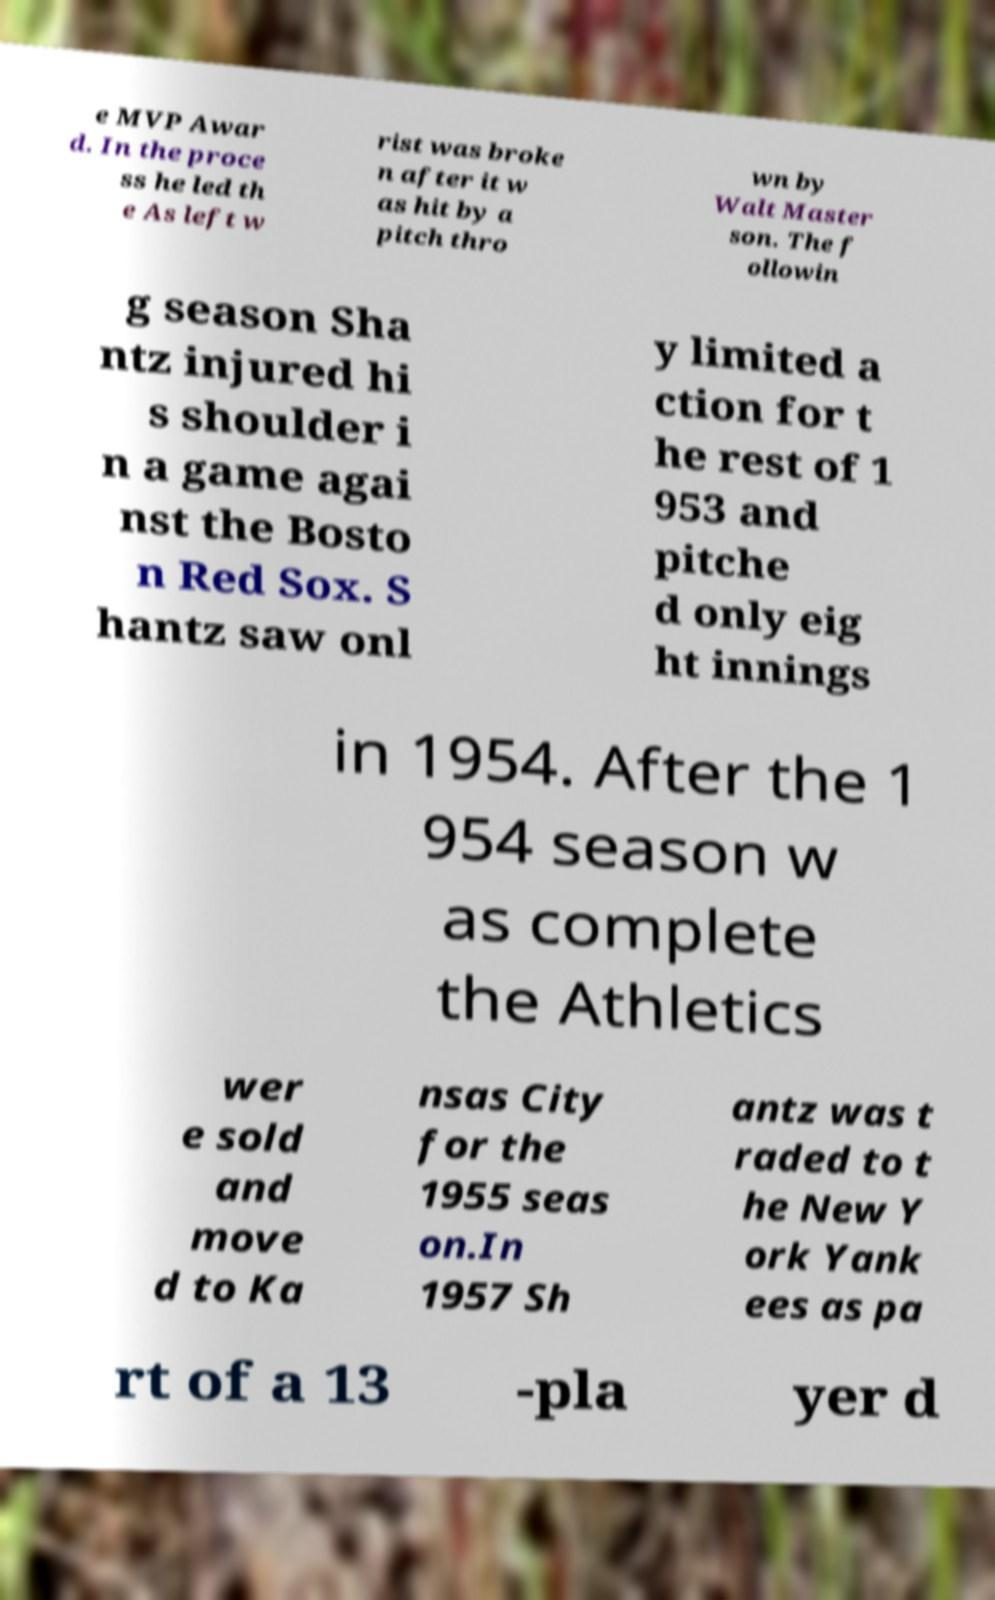Please read and relay the text visible in this image. What does it say? e MVP Awar d. In the proce ss he led th e As left w rist was broke n after it w as hit by a pitch thro wn by Walt Master son. The f ollowin g season Sha ntz injured hi s shoulder i n a game agai nst the Bosto n Red Sox. S hantz saw onl y limited a ction for t he rest of 1 953 and pitche d only eig ht innings in 1954. After the 1 954 season w as complete the Athletics wer e sold and move d to Ka nsas City for the 1955 seas on.In 1957 Sh antz was t raded to t he New Y ork Yank ees as pa rt of a 13 -pla yer d 